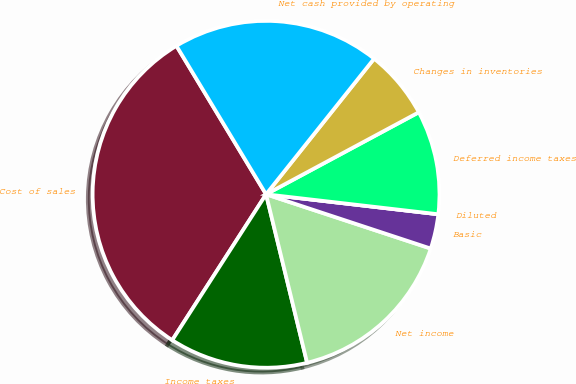<chart> <loc_0><loc_0><loc_500><loc_500><pie_chart><fcel>Cost of sales<fcel>Income taxes<fcel>Net income<fcel>Basic<fcel>Diluted<fcel>Deferred income taxes<fcel>Changes in inventories<fcel>Net cash provided by operating<nl><fcel>32.26%<fcel>12.9%<fcel>16.13%<fcel>3.23%<fcel>0.0%<fcel>9.68%<fcel>6.45%<fcel>19.35%<nl></chart> 